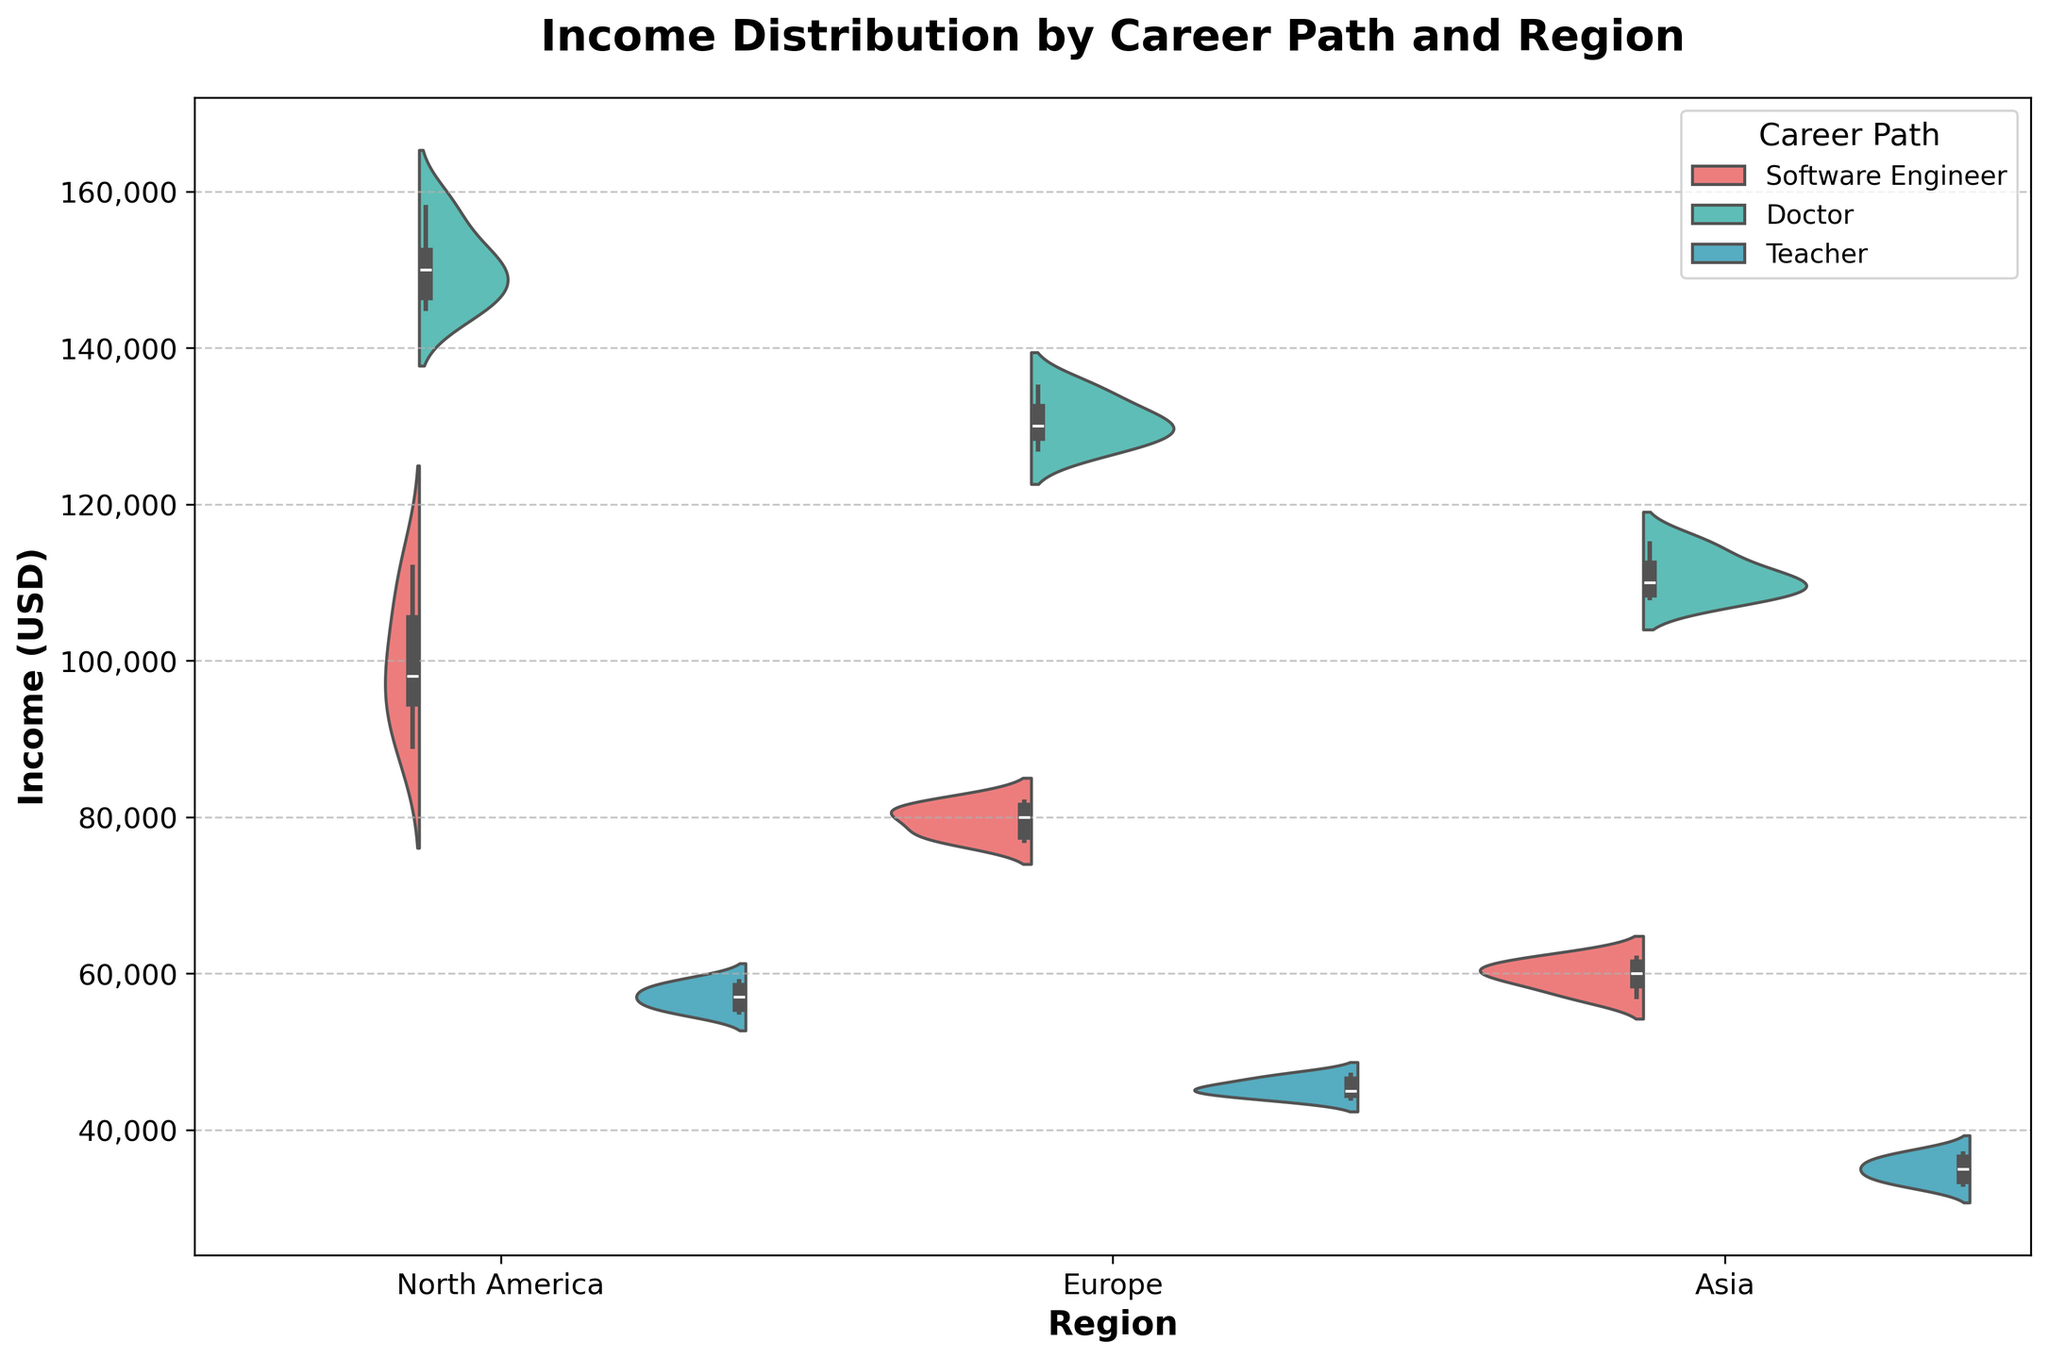What is the title of the plot? The title of the plot can be found at the top of the figure, which describes the overall topic it represents.
Answer: Income Distribution by Career Path and Region Which region has the highest median income for Software Engineers? The violin plot with box plot overlay shows the median line within the boxes. Locate the median line for Software Engineers in each region and compare them.
Answer: North America How does the income distribution of Teachers in Asia compare to Europe? Compare the width and form of the violin plots for Teachers in Asia and Europe. A wider plot shows more variability, and the highest density areas indicate where most of the incomes lie.
Answer: Teachers in Asia have a lower and narrower distribution compared to Europe What is the general difference in median income between Doctors and Software Engineers in North America? Find the median lines for Doctors and Software Engineers in North America within their respective box plots on the violin plots and subtract the Software Engineers' median from Doctors' median.
Answer: 50,000 Which career path shows the widest range of income distribution in Europe? The range is represented by the span of the violin plot from top to bottom. Check for the career path with the most spread in Europe.
Answer: Doctor What can you infer about the symmetry of income distribution for Teachers in North America? Symmetry in the violin plot shows how evenly incomes are distributed around the median. Check if the two halves of the Teachers' violin plot in North America are similar.
Answer: Symmetric distribution Among the three regions, where do Teachers earn the least on average, and how can you tell? Look at the median lines within the violin plot boxes for Teachers across the three regions and identify the lowest one.
Answer: Asia Which region has the smallest variance in income for Software Engineers? Variance in the violin plot is indicated by the width and distribution spread. Find the region where the Software Engineers' plot is the narrowest.
Answer: Asia Are there outliers visible in the income distribution for any career path in North America? Outliers are usually indicated as points or lines distinct from the main body of the distribution in the box plot overlay. Examine each career path in North America for such points.
Answer: No visible outliers 